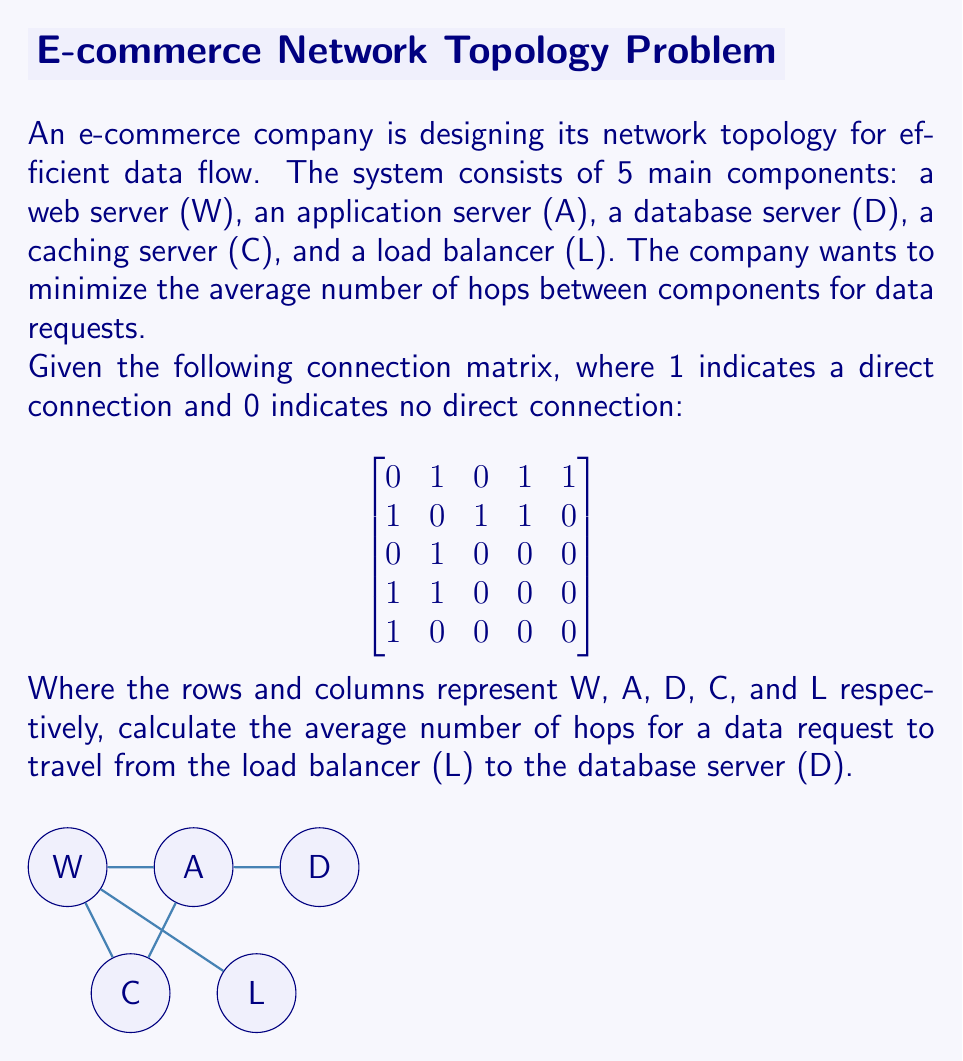Could you help me with this problem? To solve this problem, we need to follow these steps:

1) First, identify the shortest path from L to D:
   L → W → A → D

2) Count the number of hops in this path:
   - L to W: 1 hop
   - W to A: 1 hop
   - A to D: 1 hop
   Total: 3 hops

3) Calculate the average:
   Since there's only one path, the average is the same as the total.

   Average number of hops = $\frac{\text{Total number of hops}}{\text{Number of paths}} = \frac{3}{1} = 3$

Therefore, the average number of hops for a data request to travel from the load balancer (L) to the database server (D) is 3.
Answer: 3 hops 